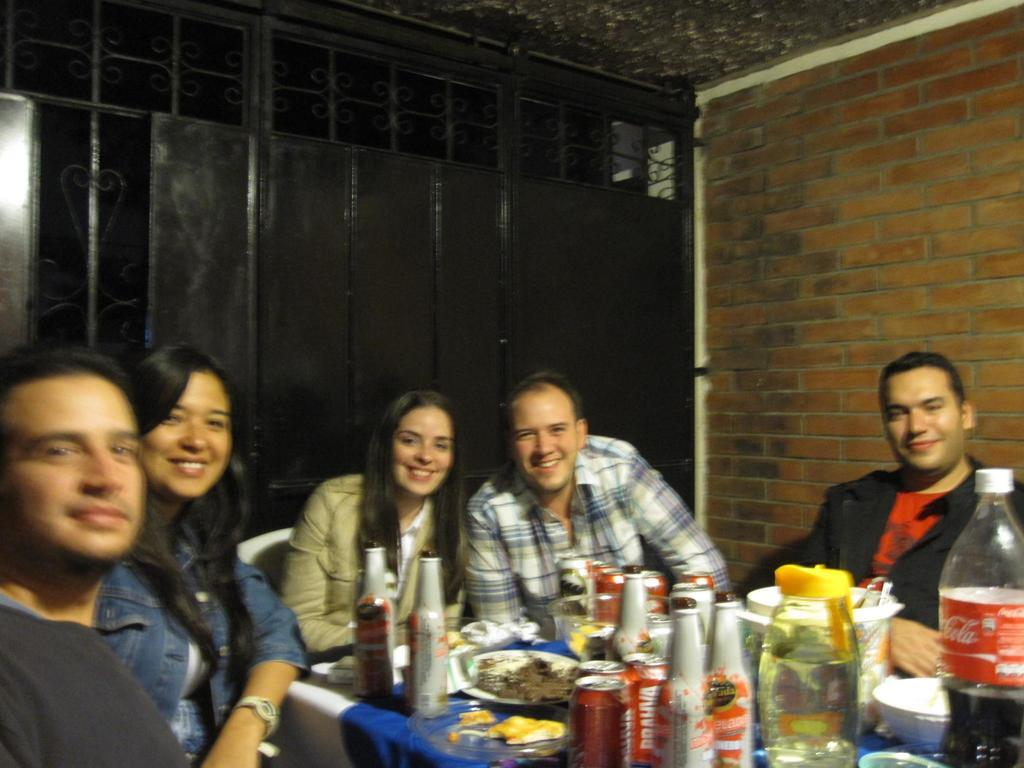What type of structure is visible in the image in the image? There is a brick wall in the image. What are the people in the image doing? The people in the image are sitting on chairs. What furniture is present in the image? There is a table in the image. What items can be seen on the table? There are bottles, plates, and food items on the table. What type of cloth is covering the toe of the person sitting on the chair? There is no cloth covering any toes in the image, as the people are sitting on chairs and their feet are not visible. 